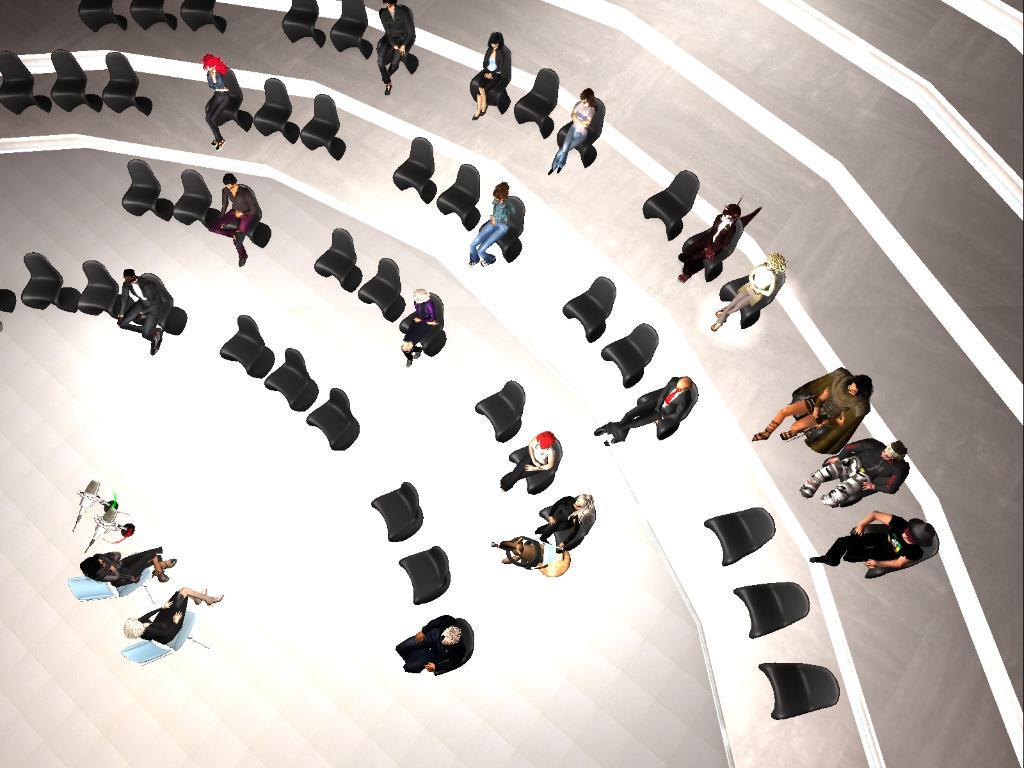What type of image is being described? The image is an animation. What are the people in the image doing? There is a group of people sitting on chairs in the image. How many chairs are visible in the image? There are many chairs in the image. What objects are present at the bottom of the image? There are microphones at the bottom of the image. What type of food is being served at the club in the image? There is no mention of a club or food in the image; it features an animation of a group of people sitting on chairs with microphones at the bottom. 